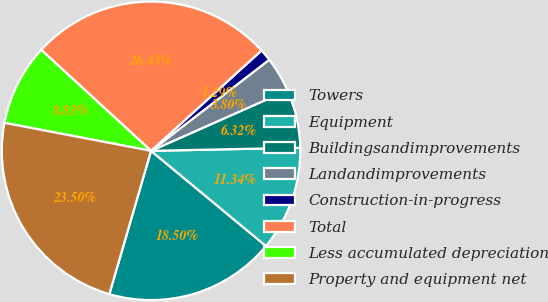<chart> <loc_0><loc_0><loc_500><loc_500><pie_chart><fcel>Towers<fcel>Equipment<fcel>Buildingsandimprovements<fcel>Landandimprovements<fcel>Construction-in-progress<fcel>Total<fcel>Less accumulated depreciation<fcel>Property and equipment net<nl><fcel>18.5%<fcel>11.34%<fcel>6.32%<fcel>3.8%<fcel>1.29%<fcel>26.43%<fcel>8.83%<fcel>23.5%<nl></chart> 